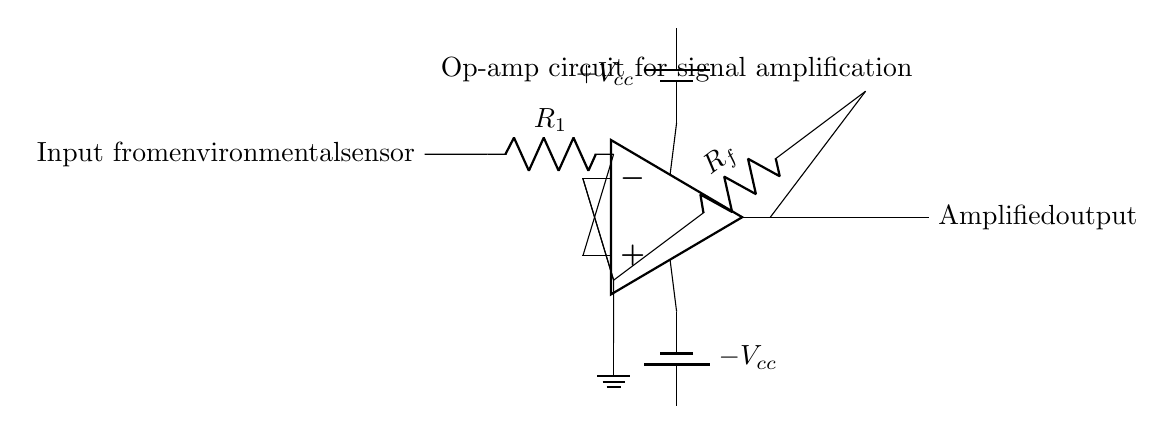What type of circuit is this? This circuit is an operational amplifier circuit, as indicated by the representation of an op-amp symbol at the center of the diagram.
Answer: Operational amplifier What is the function of resistor R1 in this circuit? Resistor R1 is typically used to limit the current from the input signal to the op-amp, providing the necessary input resistance for proper amplification.
Answer: Current limiting What is the role of the feedback resistor Rf? The feedback resistor Rf is used to set the gain of the op-amp by establishing a feedback loop from the output to the inverting terminal. This configuration helps stabilize the gain and control the amplification level.
Answer: Gain setting What are the voltage levels for Vcc? The circuit features a positive and negative power supply labeled as Vcc, which are typically necessary for powering the op-amp to allow it to amplify signals over both positive and negative voltage ranges.
Answer: Positive and negative Where does the amplified output signal originate? The amplified output signal originates from the output terminal of the op-amp, as shown on the right side of the diagram. It connects to the output line that will carry the signal to subsequent circuits or devices.
Answer: From the op-amp output What does the ground symbol represent in this circuit? The ground symbol represents a common reference point for all voltage levels in the circuit, providing a return path for current and stabilizing the voltages throughout the circuit.
Answer: Common reference point 